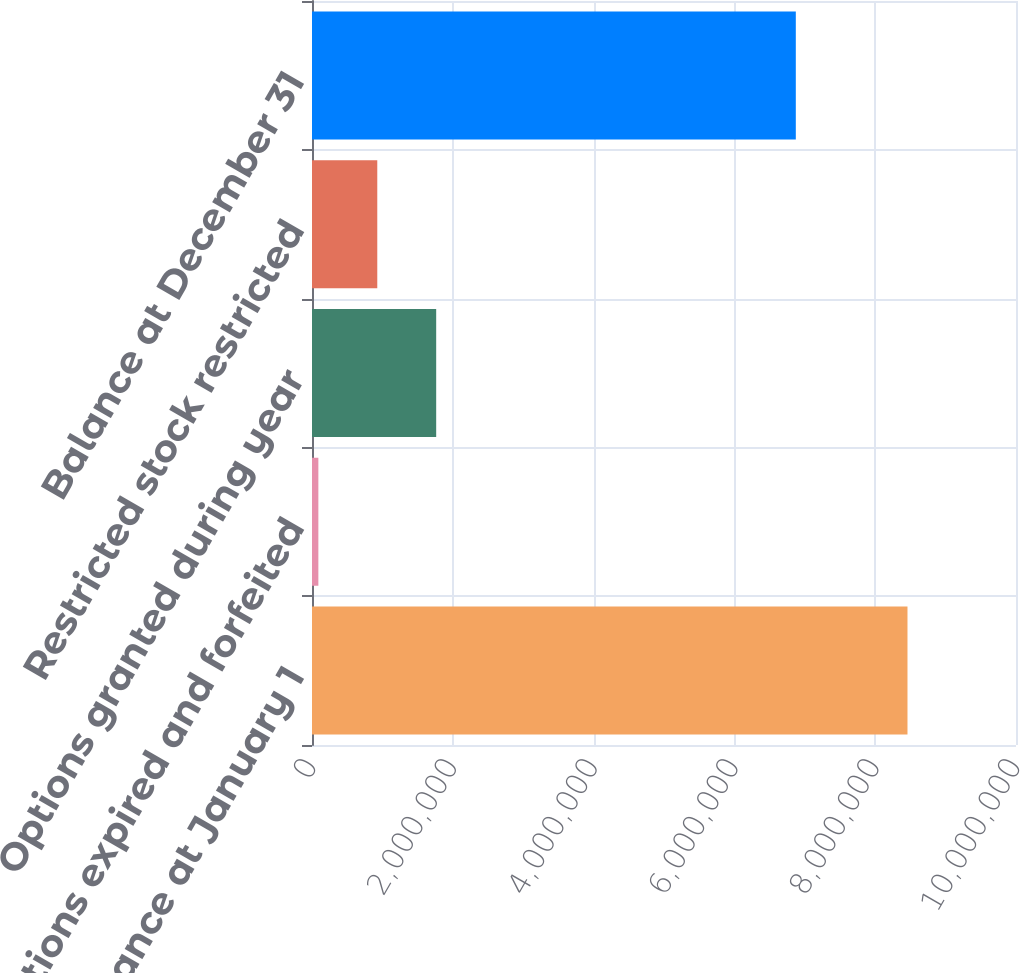<chart> <loc_0><loc_0><loc_500><loc_500><bar_chart><fcel>Balance at January 1<fcel>Options expired and forfeited<fcel>Options granted during year<fcel>Restricted stock restricted<fcel>Balance at December 31<nl><fcel>8.45859e+06<fcel>90371<fcel>1.76402e+06<fcel>927193<fcel>6.87228e+06<nl></chart> 